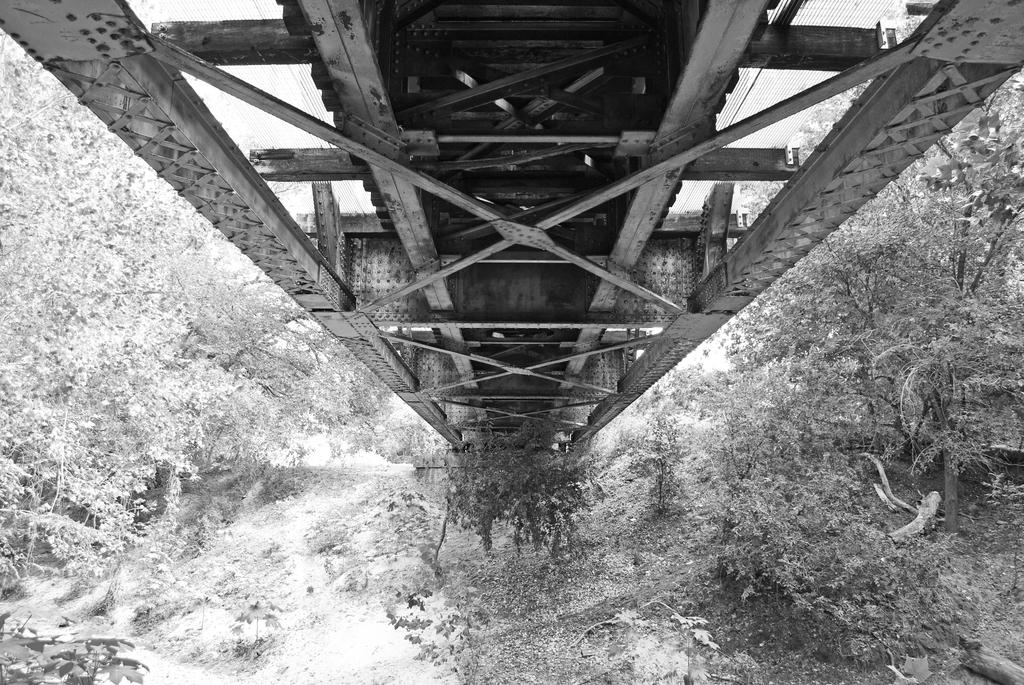What type of structure can be seen in the image? There is a bridge in the image. What natural elements are present in the image? There are many trees and plants in the image. What type of star can be seen in the image? There is no star present in the image. What type of chain can be seen in the image? There is no chain present in the image. 